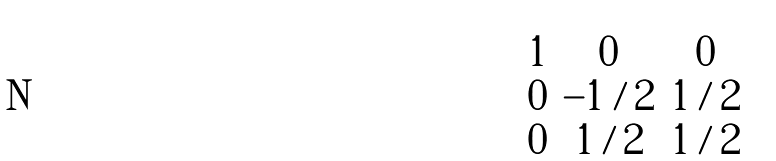Convert formula to latex. <formula><loc_0><loc_0><loc_500><loc_500>\begin{bmatrix} 1 & 0 & 0 \\ 0 & - 1 / 2 & 1 / 2 \\ 0 & 1 / 2 & 1 / 2 \\ \end{bmatrix}</formula> 